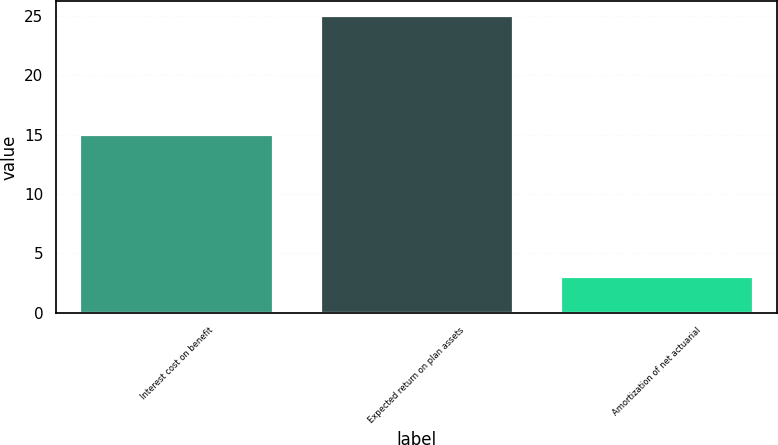Convert chart to OTSL. <chart><loc_0><loc_0><loc_500><loc_500><bar_chart><fcel>Interest cost on benefit<fcel>Expected return on plan assets<fcel>Amortization of net actuarial<nl><fcel>15<fcel>25<fcel>3<nl></chart> 